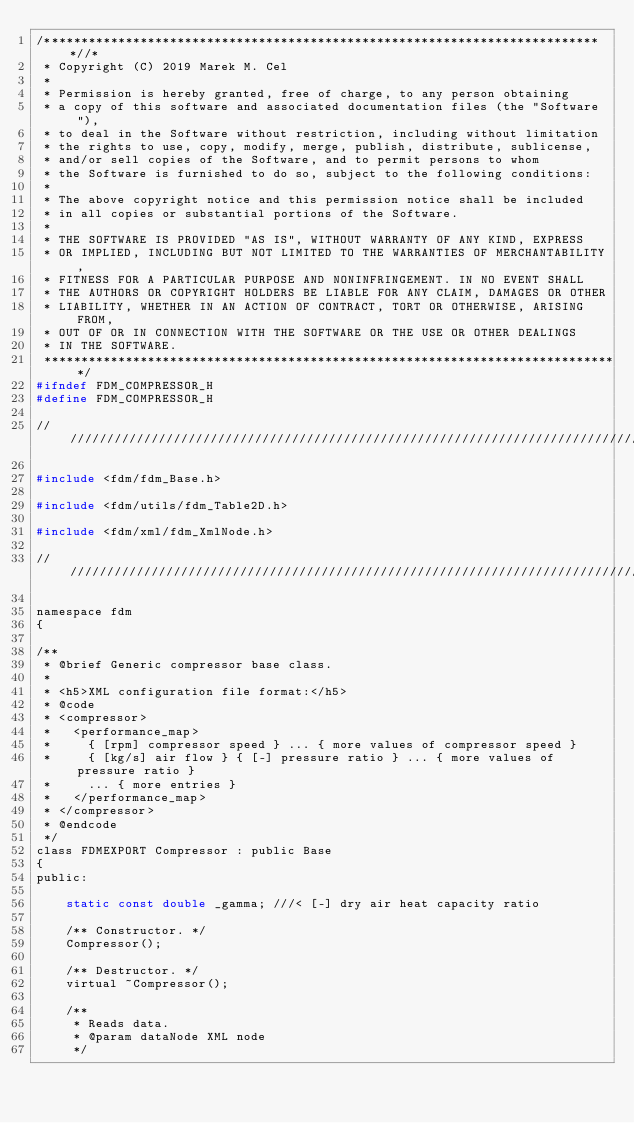<code> <loc_0><loc_0><loc_500><loc_500><_C_>/****************************************************************************//*
 * Copyright (C) 2019 Marek M. Cel
 *
 * Permission is hereby granted, free of charge, to any person obtaining
 * a copy of this software and associated documentation files (the "Software"),
 * to deal in the Software without restriction, including without limitation
 * the rights to use, copy, modify, merge, publish, distribute, sublicense,
 * and/or sell copies of the Software, and to permit persons to whom
 * the Software is furnished to do so, subject to the following conditions:
 *
 * The above copyright notice and this permission notice shall be included
 * in all copies or substantial portions of the Software.
 *
 * THE SOFTWARE IS PROVIDED "AS IS", WITHOUT WARRANTY OF ANY KIND, EXPRESS
 * OR IMPLIED, INCLUDING BUT NOT LIMITED TO THE WARRANTIES OF MERCHANTABILITY,
 * FITNESS FOR A PARTICULAR PURPOSE AND NONINFRINGEMENT. IN NO EVENT SHALL
 * THE AUTHORS OR COPYRIGHT HOLDERS BE LIABLE FOR ANY CLAIM, DAMAGES OR OTHER
 * LIABILITY, WHETHER IN AN ACTION OF CONTRACT, TORT OR OTHERWISE, ARISING FROM,
 * OUT OF OR IN CONNECTION WITH THE SOFTWARE OR THE USE OR OTHER DEALINGS
 * IN THE SOFTWARE.
 ******************************************************************************/
#ifndef FDM_COMPRESSOR_H
#define FDM_COMPRESSOR_H

////////////////////////////////////////////////////////////////////////////////

#include <fdm/fdm_Base.h>

#include <fdm/utils/fdm_Table2D.h>

#include <fdm/xml/fdm_XmlNode.h>

////////////////////////////////////////////////////////////////////////////////

namespace fdm
{

/**
 * @brief Generic compressor base class.
 *
 * <h5>XML configuration file format:</h5>
 * @code
 * <compressor>
 *   <performance_map>
 *     { [rpm] compressor speed } ... { more values of compressor speed }
 *     { [kg/s] air flow } { [-] pressure ratio } ... { more values of pressure ratio }
 *     ... { more entries }
 *   </performance_map>
 * </compressor>
 * @endcode
 */
class FDMEXPORT Compressor : public Base
{
public:

    static const double _gamma; ///< [-] dry air heat capacity ratio

    /** Constructor. */
    Compressor();

    /** Destructor. */
    virtual ~Compressor();

    /**
     * Reads data.
     * @param dataNode XML node
     */</code> 